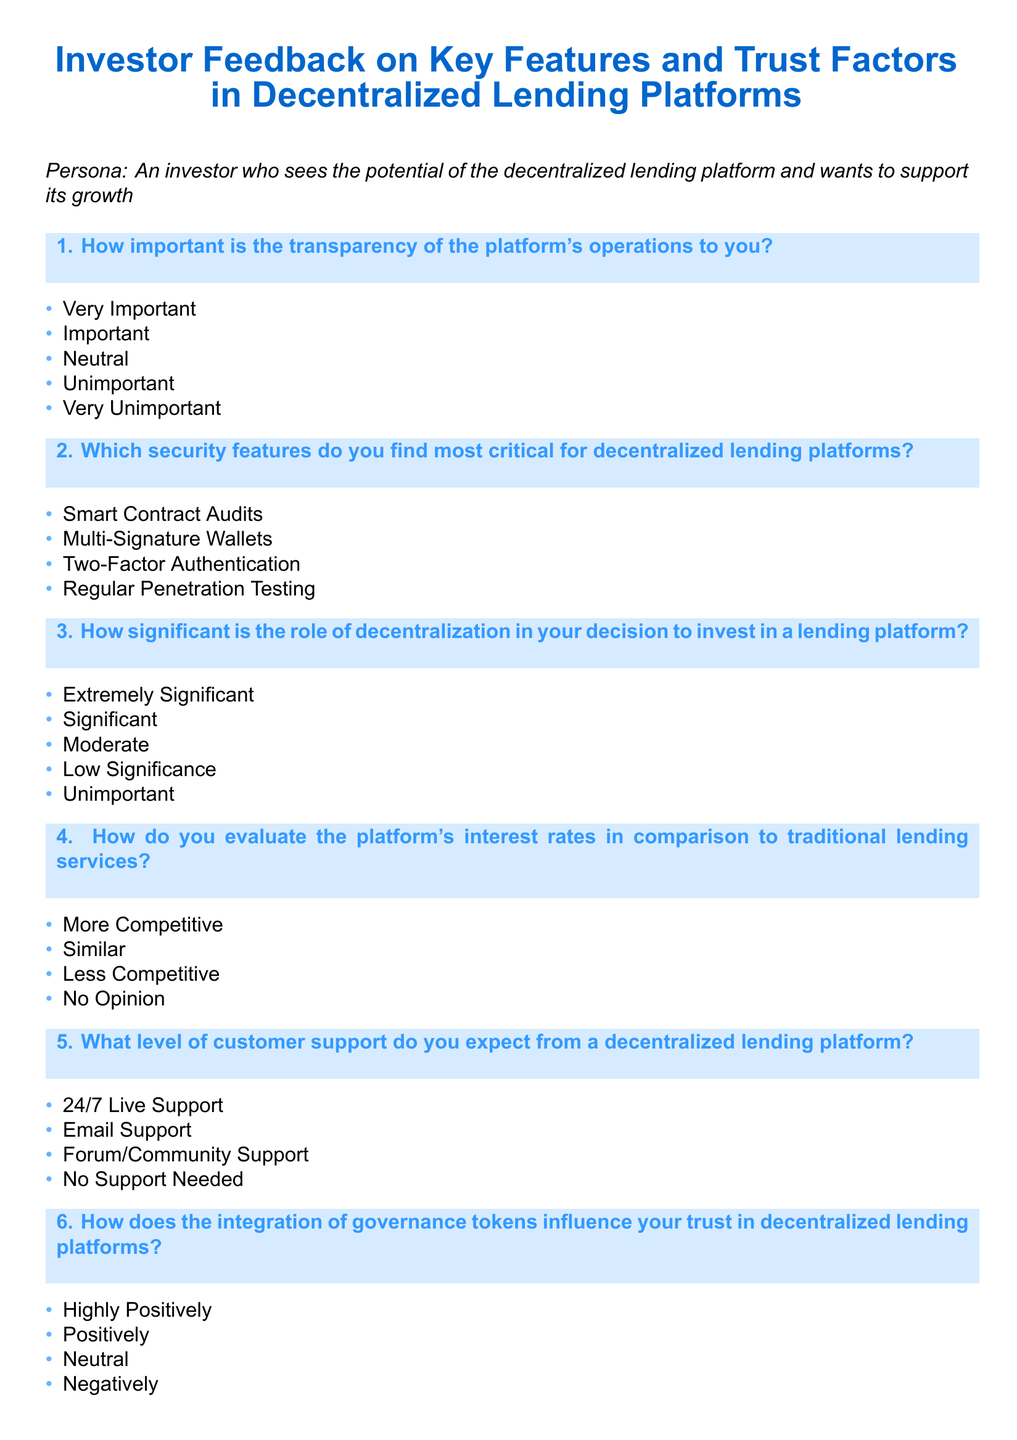What is the title of the document? The title is stated at the top of the document in a larger font size.
Answer: Investor Feedback on Key Features and Trust Factors in Decentralized Lending Platforms How many security features are listed in the document? The document provides a list of four critical security features for decentralized lending platforms.
Answer: Four What is the first question asked in the questionnaire? The first question pertains to the importance of transparency, as indicated in the question box.
Answer: How important is the transparency of the platform's operations to you? Which response option indicates a positive view on governance tokens? Positive views are categorized clearly in the selection options for the question related to governance tokens.
Answer: Highly Positively What is the expected level of customer support mentioned? The document lists four potential levels of customer support that investors might expect.
Answer: 24/7 Live Support How many options are provided for evaluating interest rates? The document presents four distinct response options for evaluating interest rates.
Answer: Four 